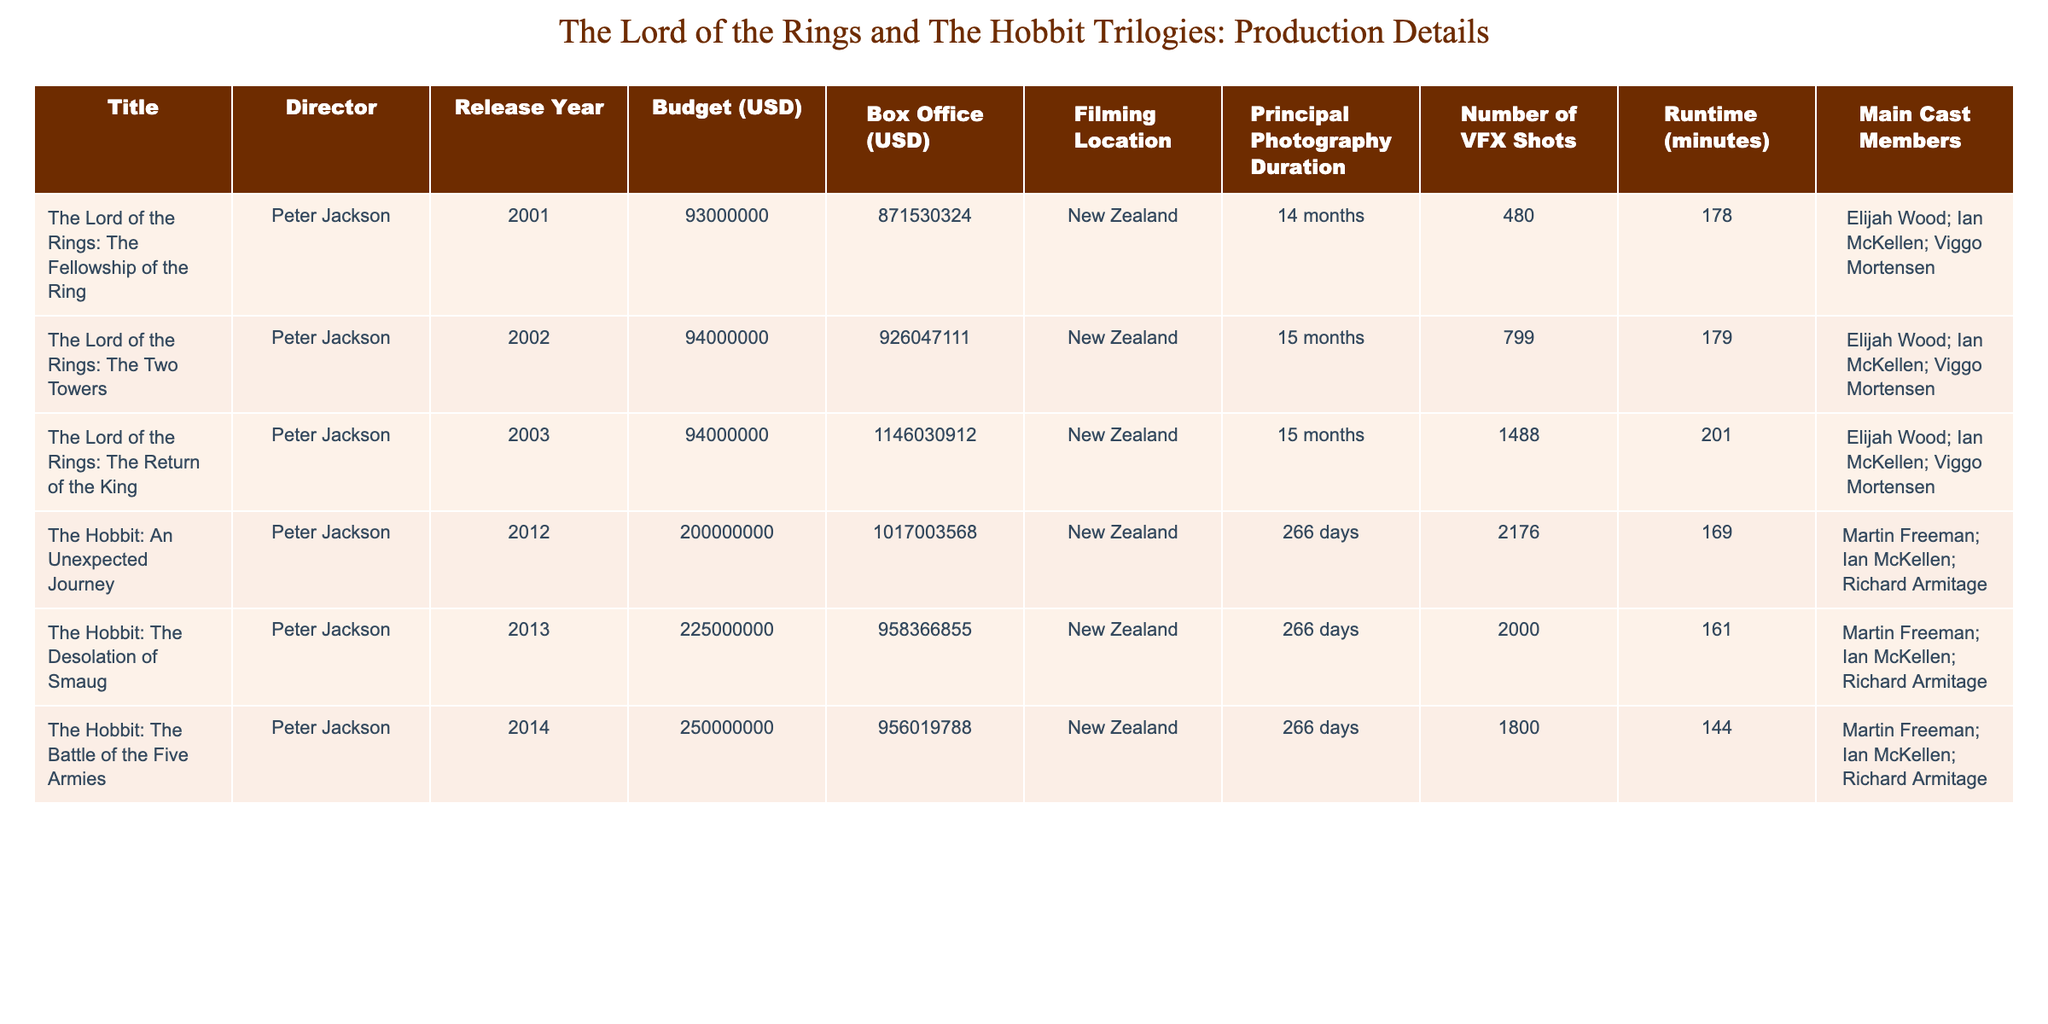What is the budget for "The Lord of the Rings: The Two Towers"? The budget is listed directly in the table under the "Budget (USD)" column for that specific film. For "The Lord of the Rings: The Two Towers," the budget is $94,000,000.
Answer: 94000000 Which film had the highest box office revenue? The box office revenue can be found in the "Box Office (USD)" column. Comparing the values, "The Lord of the Rings: The Return of the King" had the highest revenue at $1,146,030,912.
Answer: 1146030912 How many months did principal photography last for "The Hobbit: An Unexpected Journey"? The duration of principal photography is recorded in the "Principal Photography Duration" column. For "The Hobbit: An Unexpected Journey," it lasted 266 days, which is approximately 8.8 months.
Answer: 266 days What is the average budget of the original "The Lord of the Rings" trilogy? The budgets for the three films are $93,000,000, $94,000,000, and $94,000,000. Adding these gives $281,000,000. Dividing by 3 (the number of films) results in an average budget of $93,666,667.
Answer: 93666667 Did any of the Hobbit films have a lower box office than any of the Lord of the Rings films? By comparing the "Box Office (USD)" values, all Hobbit films had lower box office returns than "The Lord of the Rings: The Return of the King," which had the highest return of $1,146,030,912. Thus, it is true that at least one Hobbit film had a lower box office revenue than a Lord of the Rings film.
Answer: Yes What was the total number of VFX shots used in the Hobbit trilogy? The total number of VFX shots for each Hobbit film is 2176, 2000, and 1800. Summing these gives 2176 + 2000 + 1800 = 5976 VFX shots.
Answer: 5976 Which film has the longest runtime? Checking the "Runtime (minutes)" column, we see that "The Lord of the Rings: The Return of the King" has the longest runtime at 201 minutes.
Answer: 201 How many more visual effects shots were there in "The Lord of the Rings: The Return of the King" compared to "The Fellowship of the Ring"? The VFX shots for these films are 1488 (Return of the King) and 480 (Fellowship of the Ring). Subtracting gives 1488 - 480 = 1008 more visual effects shots in Return of the King.
Answer: 1008 What percentage of the total budget of the original trilogy was spent on "The Lord of the Rings: The Fellowship of the Ring"? The total budget for the trilogy is $93,000,000 + $94,000,000 + $94,000,000 = $281,000,000. The budget for Fellowship is $93,000,000. Thus, the percentage is (93,000,000 / 281,000,000) * 100 ≈ 33.1%.
Answer: 33.1% 